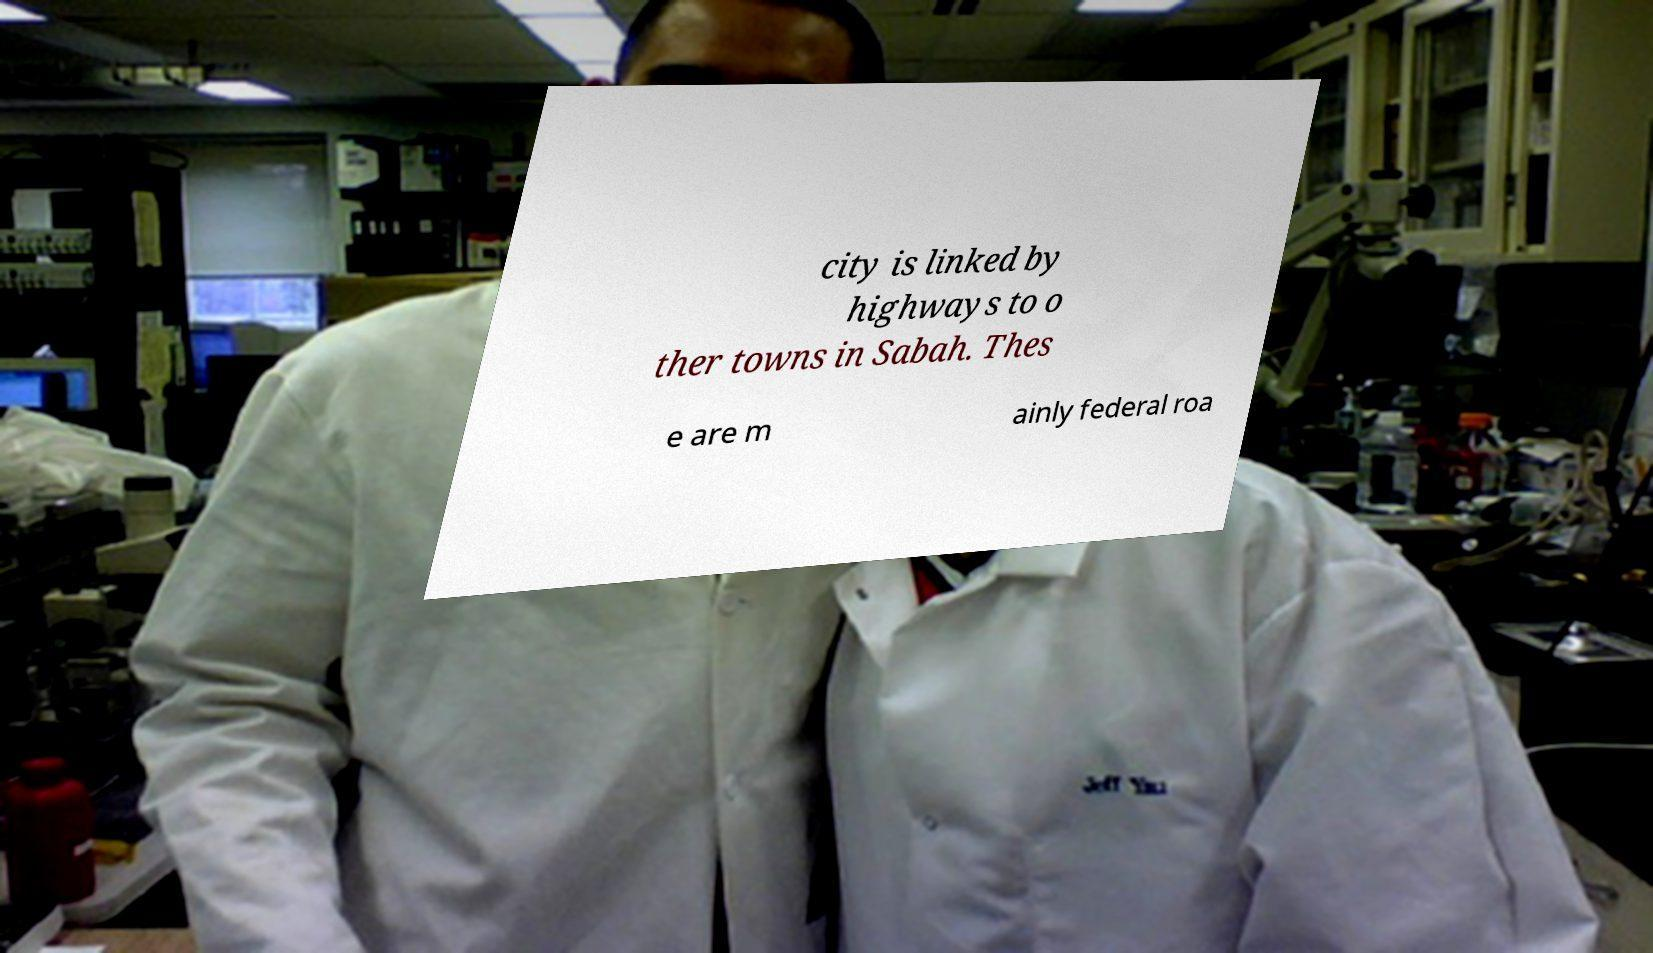Can you read and provide the text displayed in the image?This photo seems to have some interesting text. Can you extract and type it out for me? city is linked by highways to o ther towns in Sabah. Thes e are m ainly federal roa 